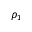<formula> <loc_0><loc_0><loc_500><loc_500>\rho _ { 1 }</formula> 